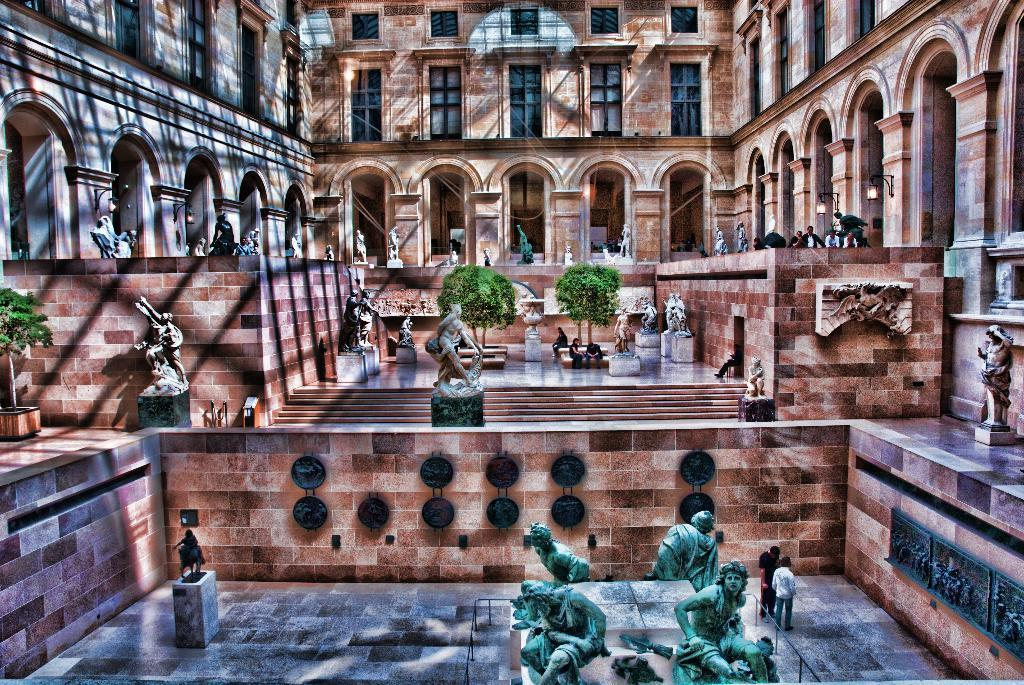What type of structures can be seen in the image? There are walls, windows, pillars, and statues in the image. What type of vegetation is present in the image? There are trees in the image. What architectural feature is visible in the image? There are stairs in the image. What are some of the people in the image doing? Some people are standing, and some are sitting on a bench. How many cakes can be seen on the plough in the image? There is no plough or cakes present in the image. What is the distance between the two furthest people in the image? The provided facts do not mention any specific distances between people, so it cannot be determined. 